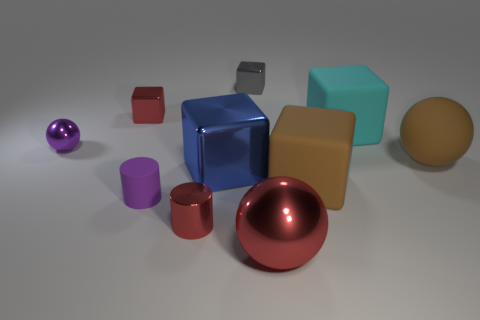Subtract all cyan cubes. How many cubes are left? 4 Subtract all small gray cubes. How many cubes are left? 4 Subtract all green cylinders. Subtract all green blocks. How many cylinders are left? 2 Subtract all balls. How many objects are left? 7 Subtract all cyan objects. Subtract all small brown metal blocks. How many objects are left? 9 Add 8 brown rubber spheres. How many brown rubber spheres are left? 9 Add 9 small yellow shiny spheres. How many small yellow shiny spheres exist? 9 Subtract 1 cyan cubes. How many objects are left? 9 